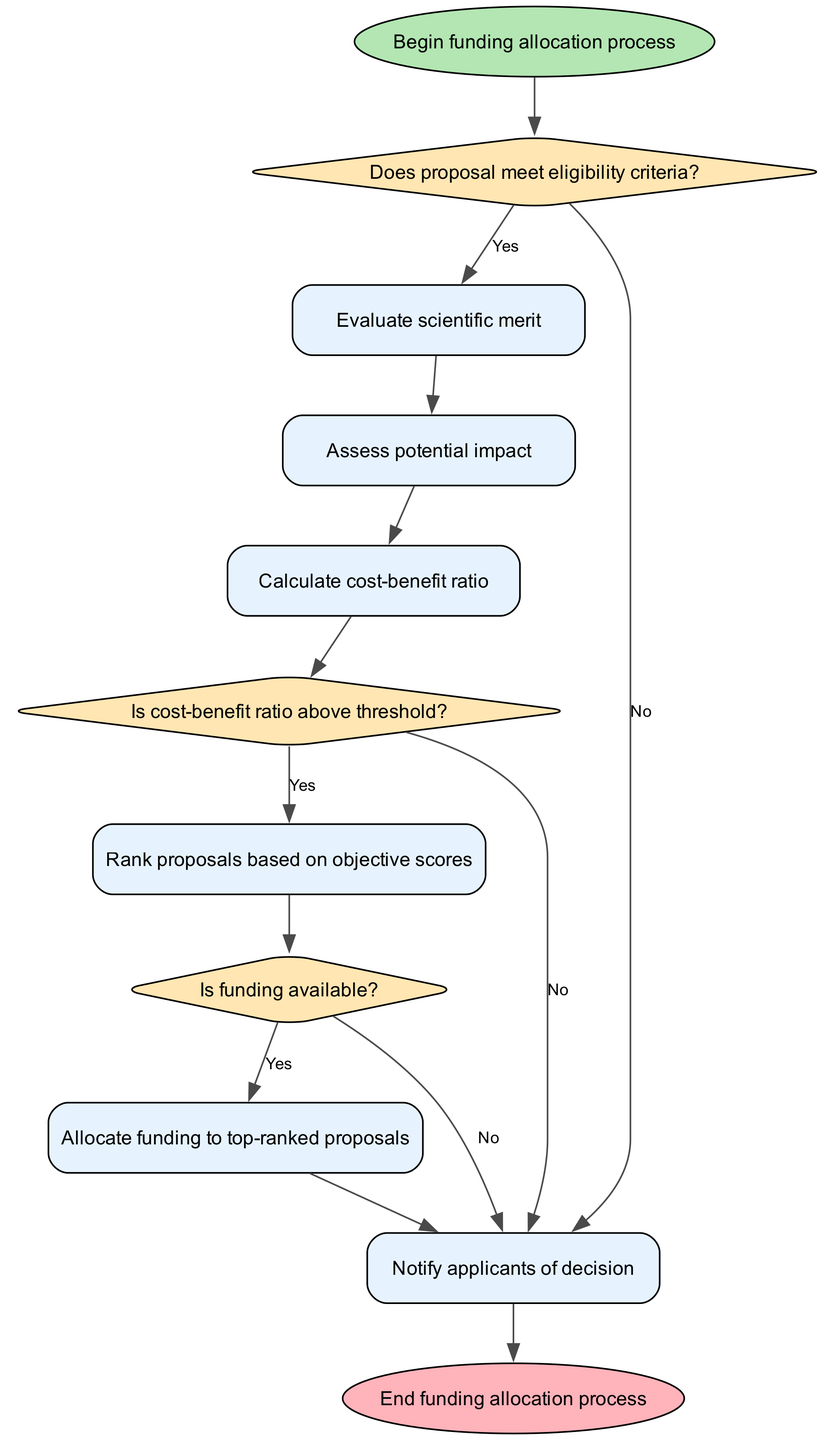What is the first step in the funding allocation process? The first step is indicated by the "start" element in the diagram, which is "Begin funding allocation process."
Answer: Begin funding allocation process What decision follows the eligibility criteria assessment? After evaluating whether the proposal meets eligibility criteria, the next step is to evaluate the scientific merit.
Answer: Evaluate scientific merit How many process nodes are present in the diagram? By counting the nodes designated as "process," we find there are five process nodes in total, which are 'Evaluate scientific merit,' 'Assess potential impact,' 'Calculate cost-benefit ratio,' 'Rank proposals based on objective scores,' and 'Allocate funding to top-ranked proposals.'
Answer: Five What happens if the proposal does not meet the eligibility criteria? If the proposal does not meet eligibility criteria, the flow indicates that applicants will be notified of the decision without further evaluation or funding allocation.
Answer: Notify applicants of decision What is required for a proposal to proceed after assessing the potential impact? After assessing potential impact, the proposal must calculate the cost-benefit ratio to determine if it meets the subsequent decision threshold.
Answer: Calculate cost-benefit ratio Is there a step to rank proposals based on subjective criteria? No, the diagram specifies that proposals are ranked based on objective scores, indicating an emphasis on measurable criteria instead of subjective opinions.
Answer: No What is the final step in the funding allocation process? The final step is to notify applicants of the decision made regarding their funding proposal, which comes after any necessary funding allocations.
Answer: Notify applicants of decision What must occur for funding to be allocated to top-ranked proposals? Funding can only be allocated if the availability of funds is confirmed; if funds are not available, the process redirects to notify applicants of the decision instead.
Answer: Is funding available? What shape represents a decision in the flowchart? In the flowchart, decisions are represented by diamond shapes, which clearly distinguish them from process and start/end nodes.
Answer: Diamond 